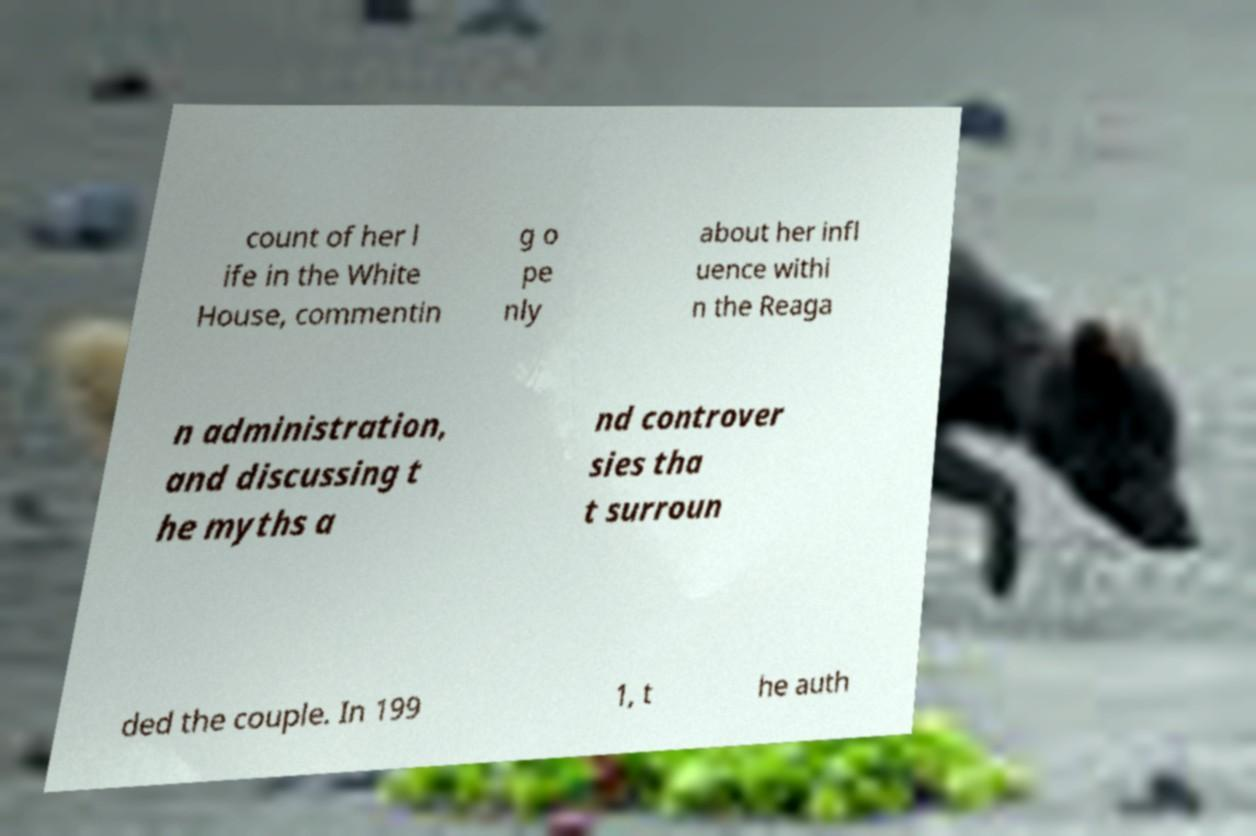Could you assist in decoding the text presented in this image and type it out clearly? count of her l ife in the White House, commentin g o pe nly about her infl uence withi n the Reaga n administration, and discussing t he myths a nd controver sies tha t surroun ded the couple. In 199 1, t he auth 